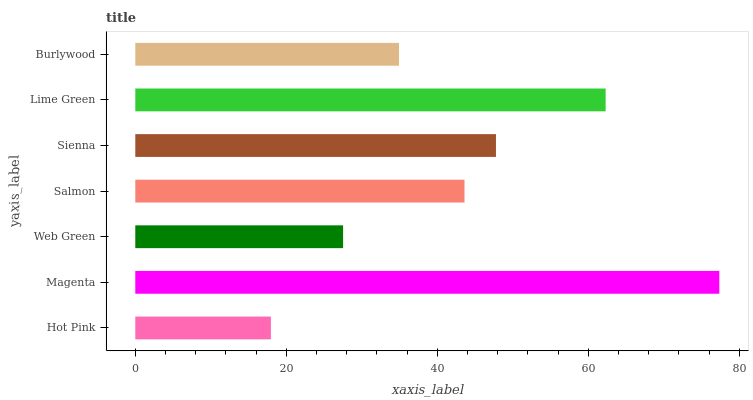Is Hot Pink the minimum?
Answer yes or no. Yes. Is Magenta the maximum?
Answer yes or no. Yes. Is Web Green the minimum?
Answer yes or no. No. Is Web Green the maximum?
Answer yes or no. No. Is Magenta greater than Web Green?
Answer yes or no. Yes. Is Web Green less than Magenta?
Answer yes or no. Yes. Is Web Green greater than Magenta?
Answer yes or no. No. Is Magenta less than Web Green?
Answer yes or no. No. Is Salmon the high median?
Answer yes or no. Yes. Is Salmon the low median?
Answer yes or no. Yes. Is Web Green the high median?
Answer yes or no. No. Is Magenta the low median?
Answer yes or no. No. 